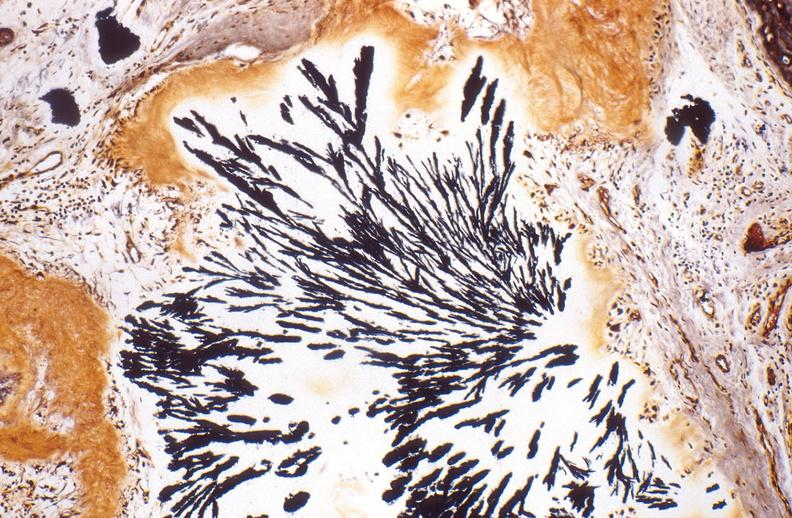does this image show gout, alcohol fixed tissues, monosodium urate crystals?
Answer the question using a single word or phrase. Yes 